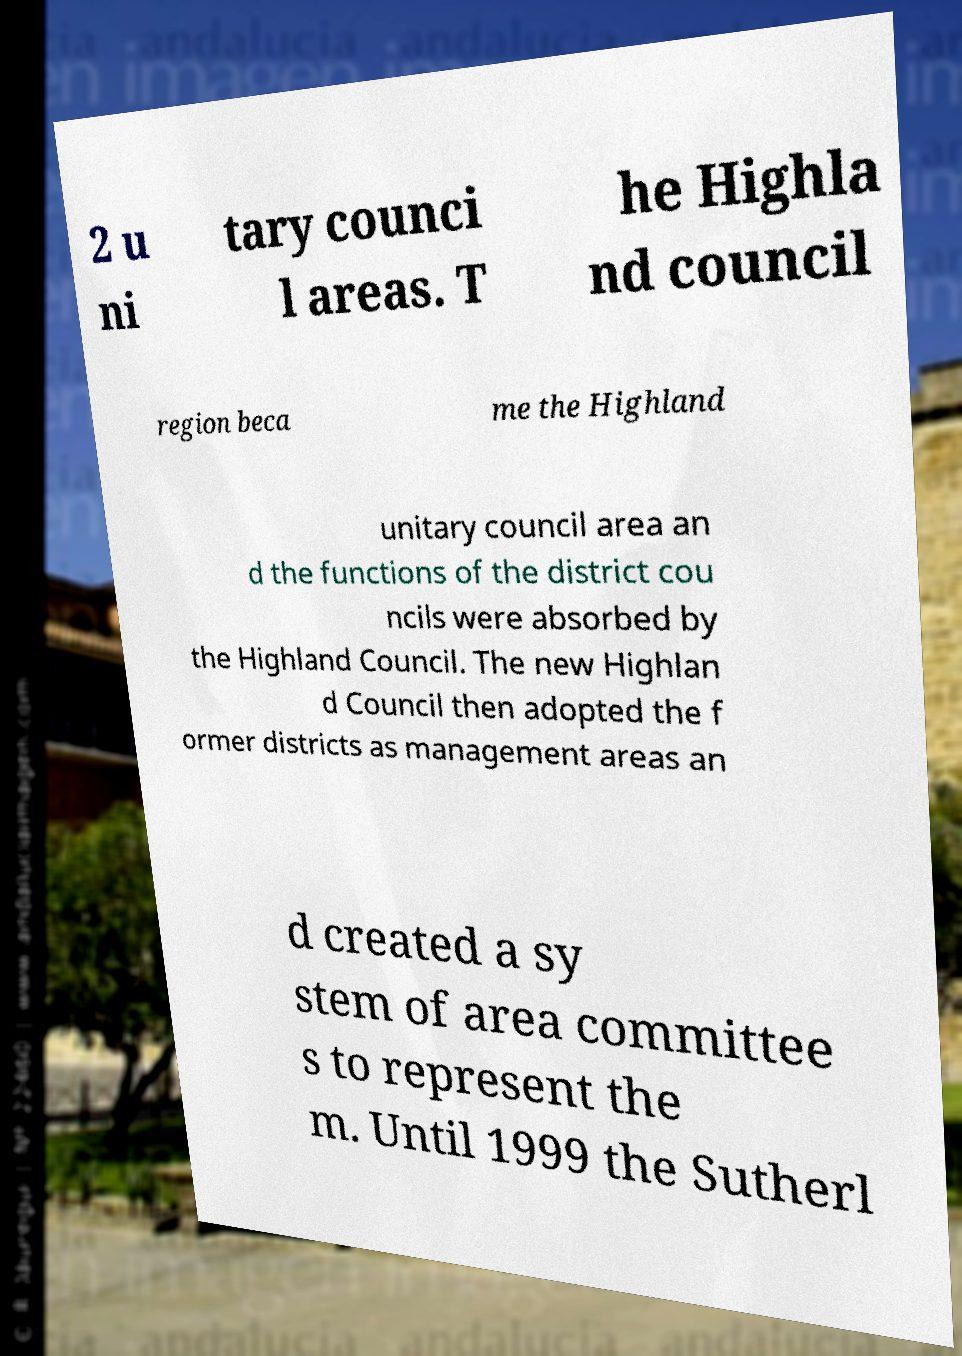Can you accurately transcribe the text from the provided image for me? 2 u ni tary counci l areas. T he Highla nd council region beca me the Highland unitary council area an d the functions of the district cou ncils were absorbed by the Highland Council. The new Highlan d Council then adopted the f ormer districts as management areas an d created a sy stem of area committee s to represent the m. Until 1999 the Sutherl 